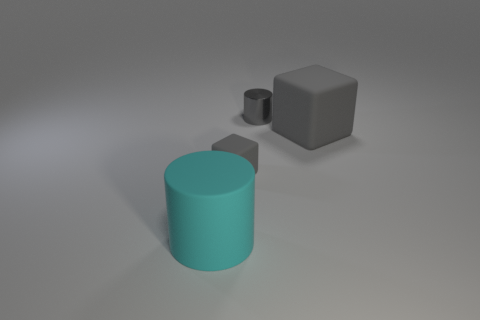Add 3 small objects. How many objects exist? 7 Subtract all small gray metal cubes. Subtract all cylinders. How many objects are left? 2 Add 4 large rubber objects. How many large rubber objects are left? 6 Add 4 gray objects. How many gray objects exist? 7 Subtract 0 yellow cylinders. How many objects are left? 4 